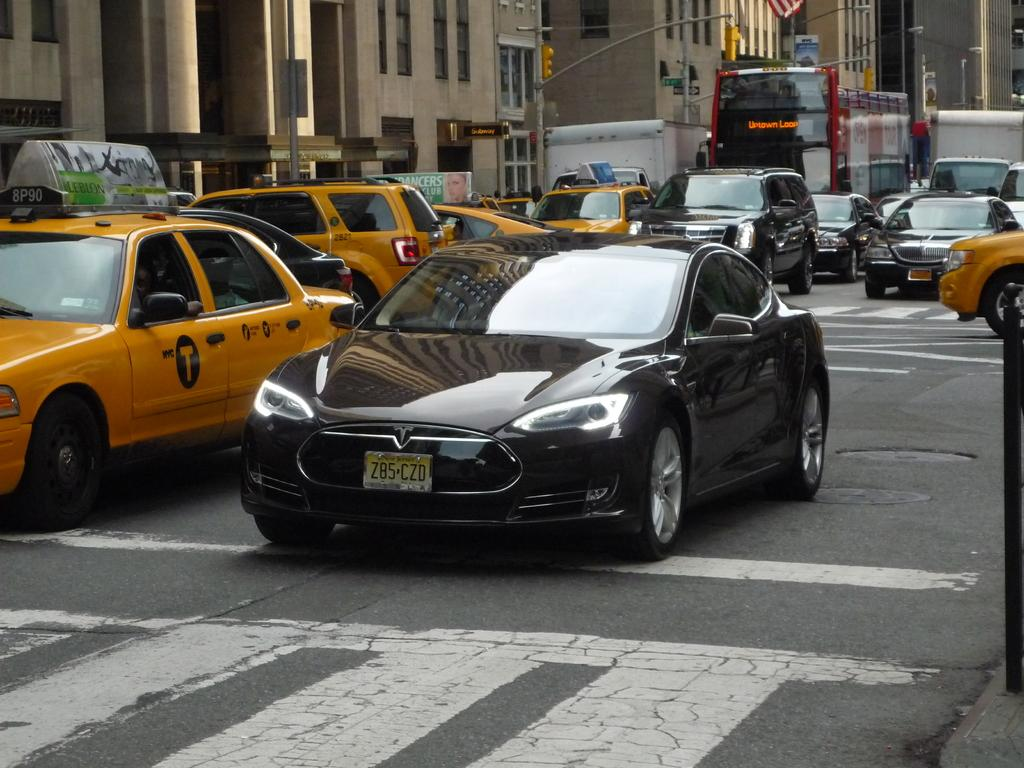What types of vehicles are in the center of the picture? There are cars, a truck, and a bus in the center of the picture. Where are the vehicles located? The vehicles are on the road. What can be seen in the background of the image? There are buildings, signal lights, street lights, a board, and other objects in the background of the image. What type of creature is sitting on the bus in the image? There is no creature sitting on the bus in the image; it only shows vehicles on the road and objects in the background. How many men are visible in the image? There is no mention of men in the image; it only features vehicles and objects in the background. 